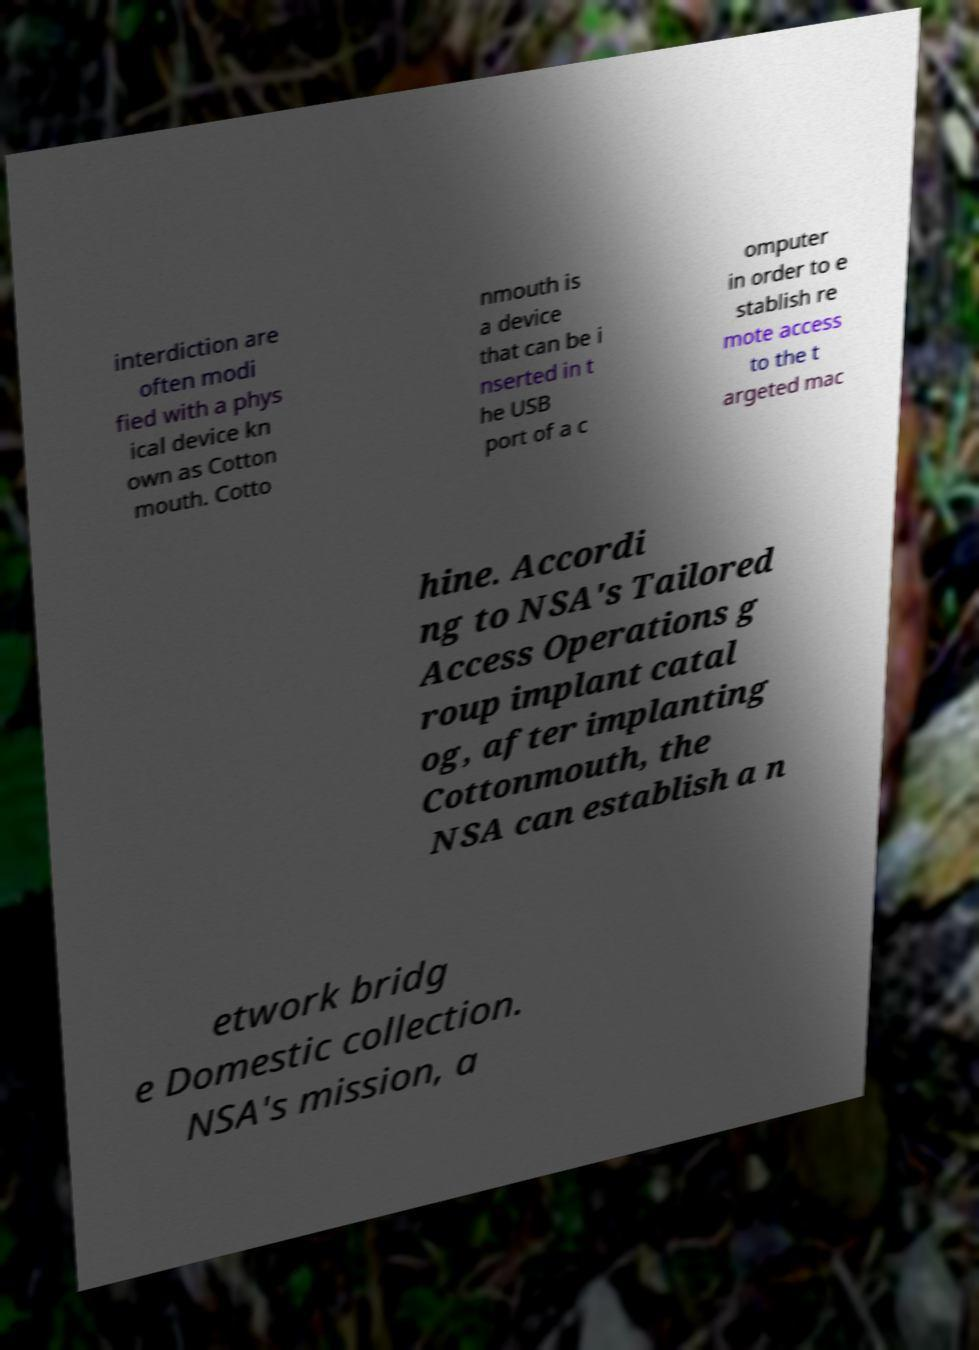Could you extract and type out the text from this image? interdiction are often modi fied with a phys ical device kn own as Cotton mouth. Cotto nmouth is a device that can be i nserted in t he USB port of a c omputer in order to e stablish re mote access to the t argeted mac hine. Accordi ng to NSA's Tailored Access Operations g roup implant catal og, after implanting Cottonmouth, the NSA can establish a n etwork bridg e Domestic collection. NSA's mission, a 